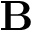<formula> <loc_0><loc_0><loc_500><loc_500>B</formula> 